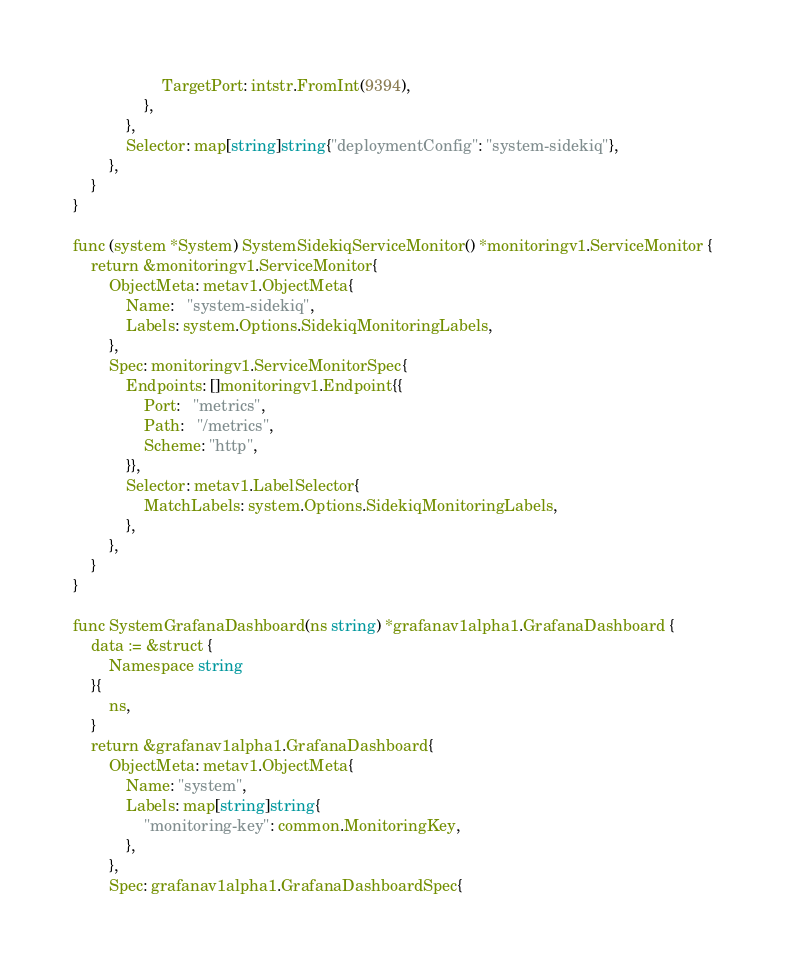<code> <loc_0><loc_0><loc_500><loc_500><_Go_>					TargetPort: intstr.FromInt(9394),
				},
			},
			Selector: map[string]string{"deploymentConfig": "system-sidekiq"},
		},
	}
}

func (system *System) SystemSidekiqServiceMonitor() *monitoringv1.ServiceMonitor {
	return &monitoringv1.ServiceMonitor{
		ObjectMeta: metav1.ObjectMeta{
			Name:   "system-sidekiq",
			Labels: system.Options.SidekiqMonitoringLabels,
		},
		Spec: monitoringv1.ServiceMonitorSpec{
			Endpoints: []monitoringv1.Endpoint{{
				Port:   "metrics",
				Path:   "/metrics",
				Scheme: "http",
			}},
			Selector: metav1.LabelSelector{
				MatchLabels: system.Options.SidekiqMonitoringLabels,
			},
		},
	}
}

func SystemGrafanaDashboard(ns string) *grafanav1alpha1.GrafanaDashboard {
	data := &struct {
		Namespace string
	}{
		ns,
	}
	return &grafanav1alpha1.GrafanaDashboard{
		ObjectMeta: metav1.ObjectMeta{
			Name: "system",
			Labels: map[string]string{
				"monitoring-key": common.MonitoringKey,
			},
		},
		Spec: grafanav1alpha1.GrafanaDashboardSpec{</code> 